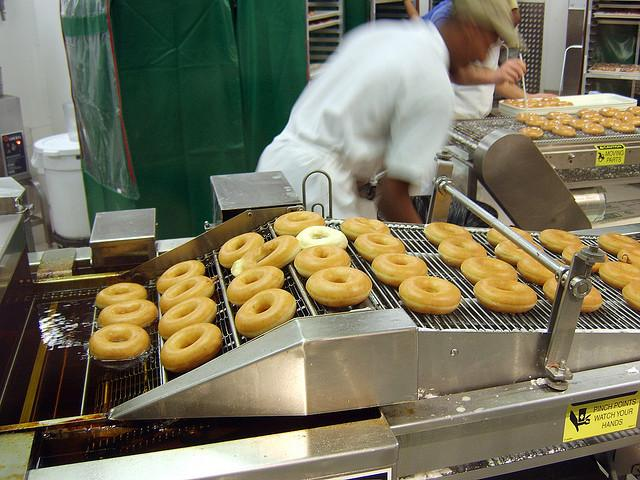What type of job are the men doing?

Choices:
A) paving
B) dancing
C) construction
D) baking baking 